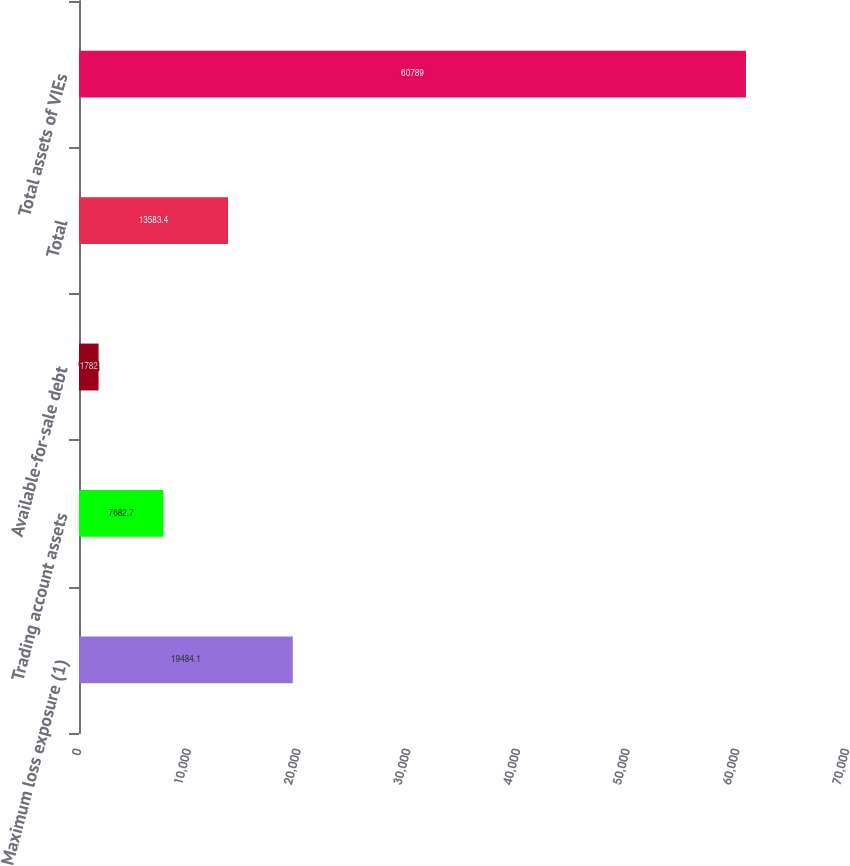Convert chart to OTSL. <chart><loc_0><loc_0><loc_500><loc_500><bar_chart><fcel>Maximum loss exposure (1)<fcel>Trading account assets<fcel>Available-for-sale debt<fcel>Total<fcel>Total assets of VIEs<nl><fcel>19484.1<fcel>7682.7<fcel>1782<fcel>13583.4<fcel>60789<nl></chart> 